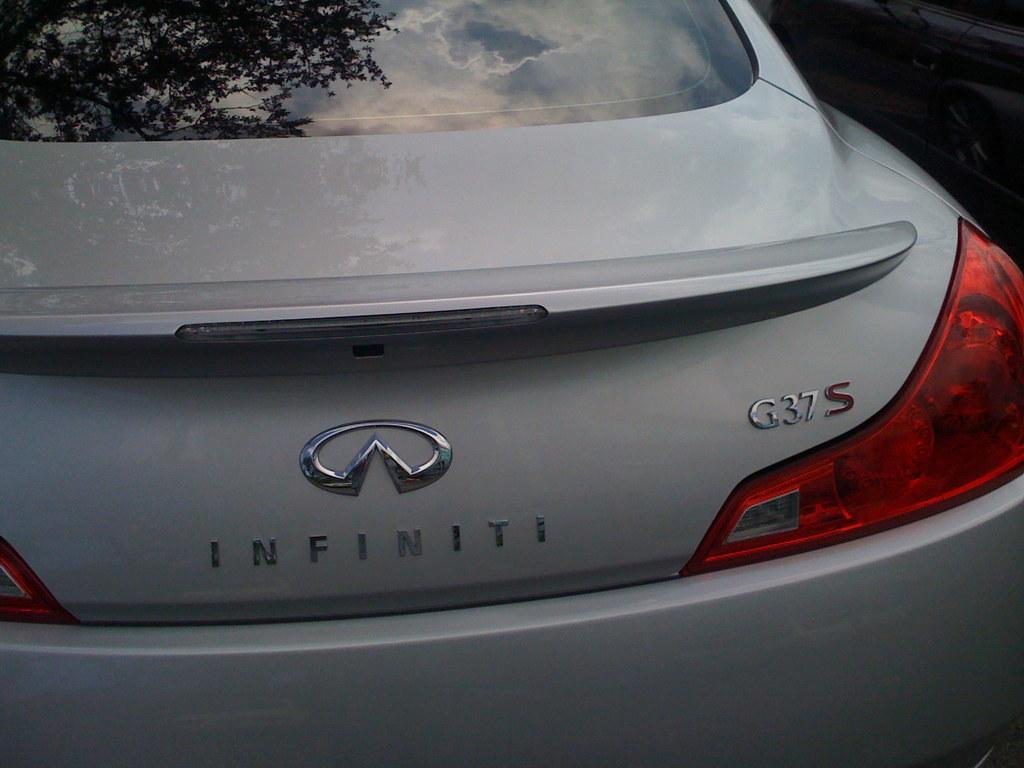What color is the car in the image? The car in the image is white-colored in the image. Where is the car located in the image? The car is in the center of the image. What type of tail is attached to the car in the image? There is no tail attached to the car in the image, as cars do not have tails. What treatment is being administered to the car in the image? There is no treatment being administered to the car in the image; it is simply parked or stationary. 